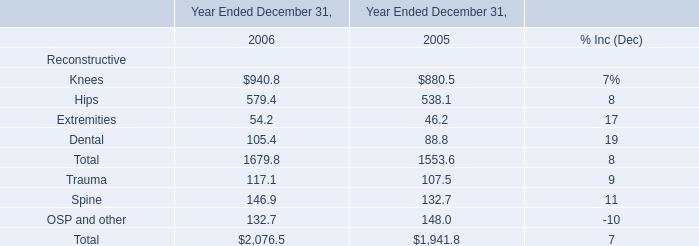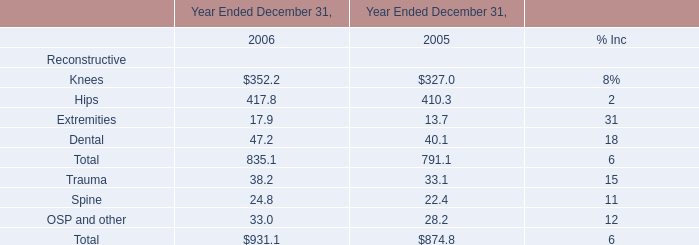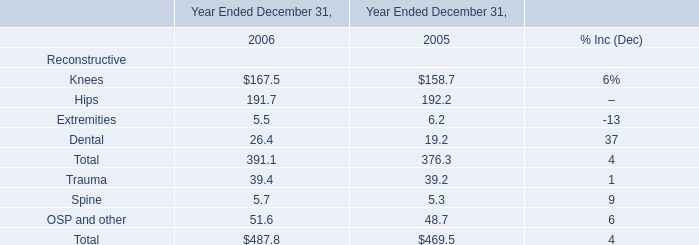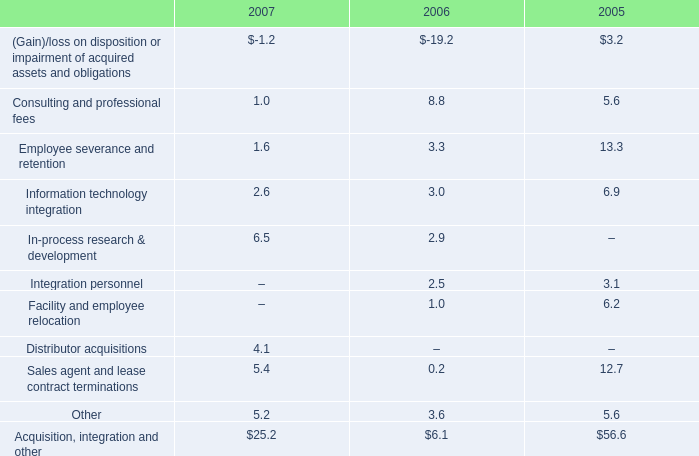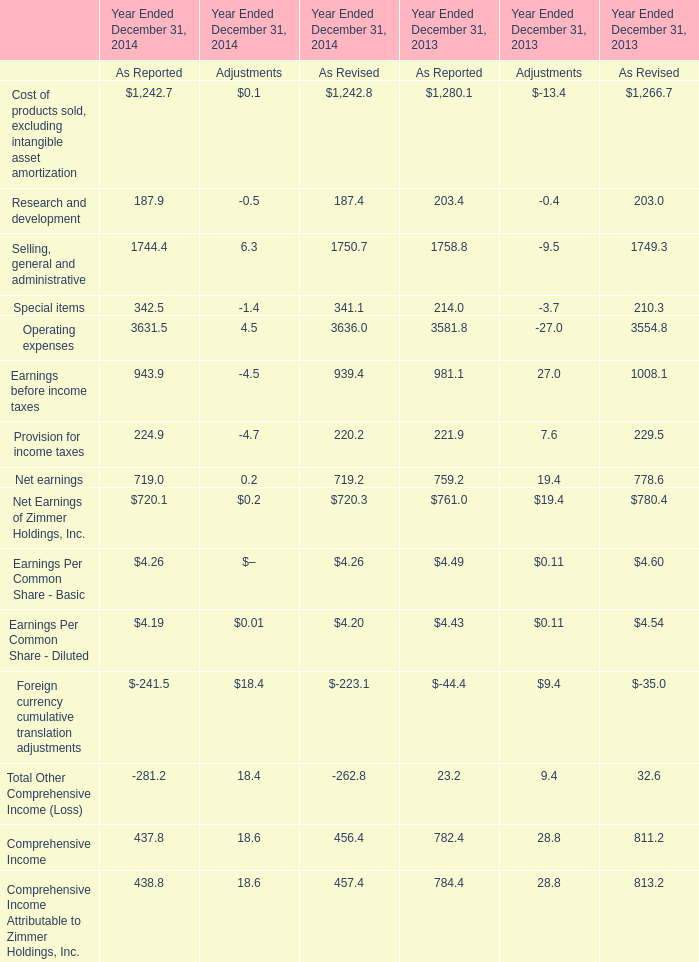what is the percent change in total acquisition integration and other expenses from 2006 to 2007? 
Computations: ((25.2 - 6.1) / 6.1)
Answer: 3.13115. 